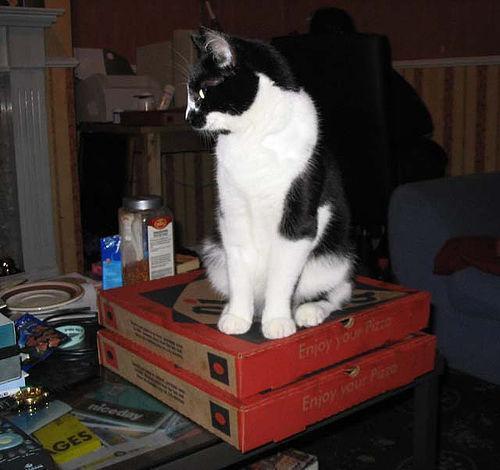How many chairs are in the picture?
Give a very brief answer. 1. 